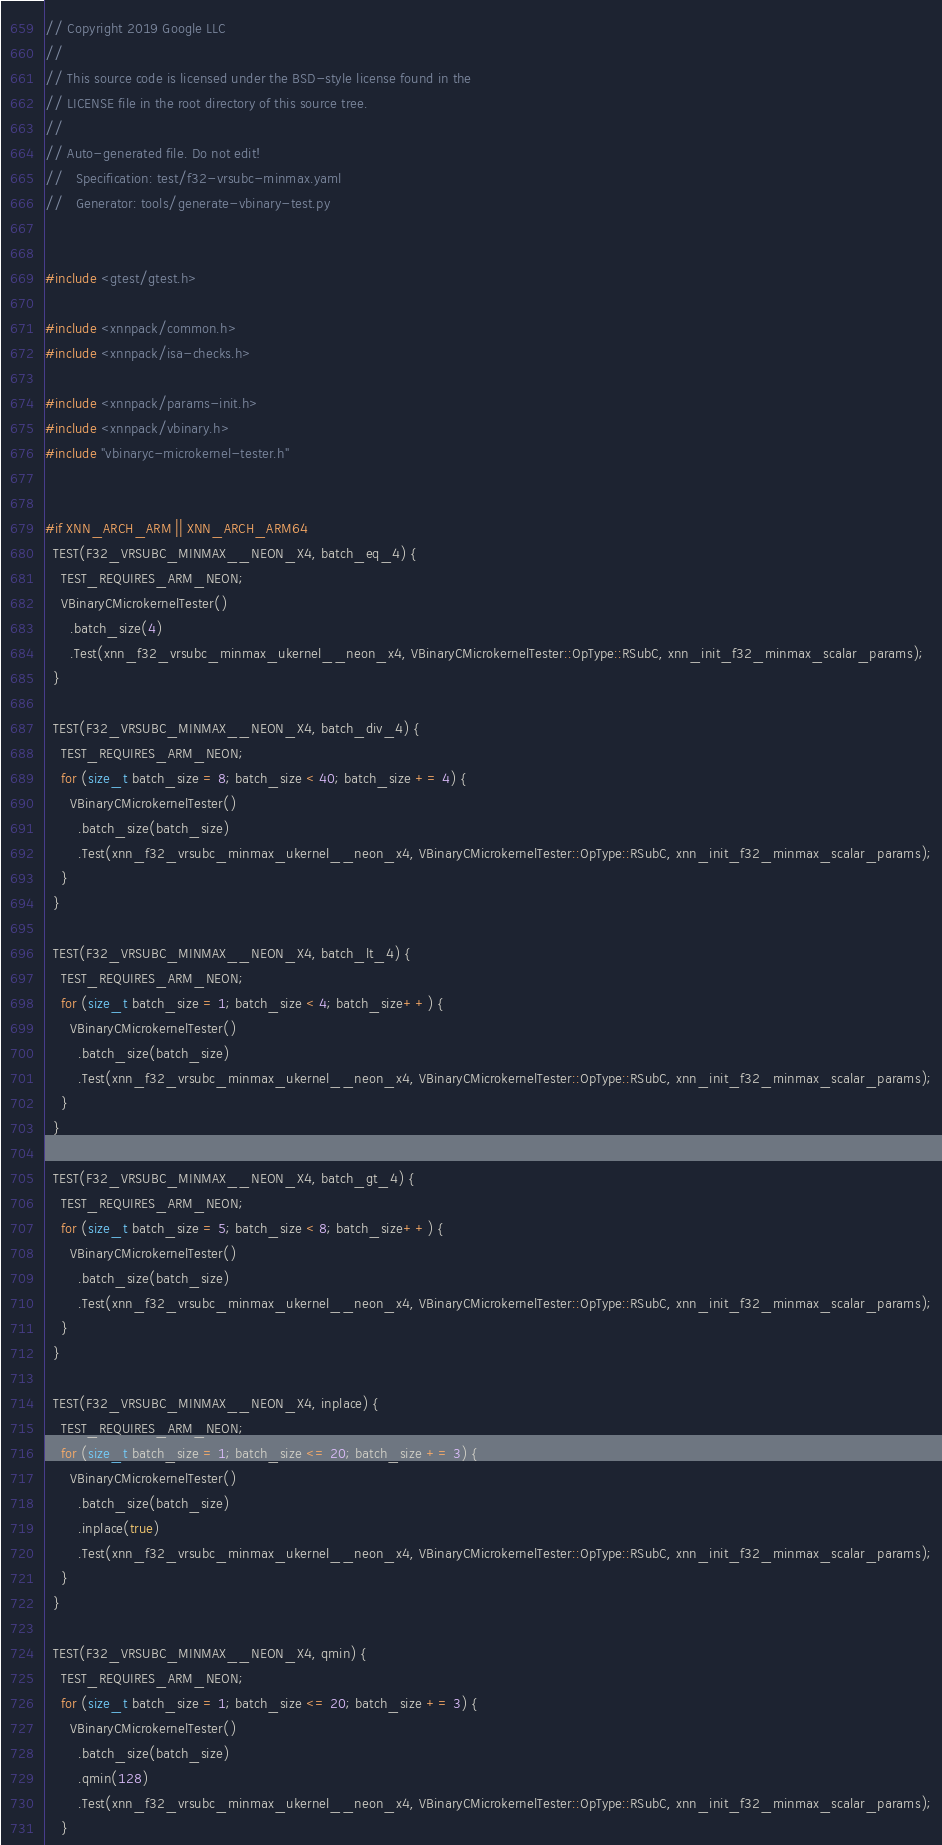<code> <loc_0><loc_0><loc_500><loc_500><_C++_>// Copyright 2019 Google LLC
//
// This source code is licensed under the BSD-style license found in the
// LICENSE file in the root directory of this source tree.
//
// Auto-generated file. Do not edit!
//   Specification: test/f32-vrsubc-minmax.yaml
//   Generator: tools/generate-vbinary-test.py


#include <gtest/gtest.h>

#include <xnnpack/common.h>
#include <xnnpack/isa-checks.h>

#include <xnnpack/params-init.h>
#include <xnnpack/vbinary.h>
#include "vbinaryc-microkernel-tester.h"


#if XNN_ARCH_ARM || XNN_ARCH_ARM64
  TEST(F32_VRSUBC_MINMAX__NEON_X4, batch_eq_4) {
    TEST_REQUIRES_ARM_NEON;
    VBinaryCMicrokernelTester()
      .batch_size(4)
      .Test(xnn_f32_vrsubc_minmax_ukernel__neon_x4, VBinaryCMicrokernelTester::OpType::RSubC, xnn_init_f32_minmax_scalar_params);
  }

  TEST(F32_VRSUBC_MINMAX__NEON_X4, batch_div_4) {
    TEST_REQUIRES_ARM_NEON;
    for (size_t batch_size = 8; batch_size < 40; batch_size += 4) {
      VBinaryCMicrokernelTester()
        .batch_size(batch_size)
        .Test(xnn_f32_vrsubc_minmax_ukernel__neon_x4, VBinaryCMicrokernelTester::OpType::RSubC, xnn_init_f32_minmax_scalar_params);
    }
  }

  TEST(F32_VRSUBC_MINMAX__NEON_X4, batch_lt_4) {
    TEST_REQUIRES_ARM_NEON;
    for (size_t batch_size = 1; batch_size < 4; batch_size++) {
      VBinaryCMicrokernelTester()
        .batch_size(batch_size)
        .Test(xnn_f32_vrsubc_minmax_ukernel__neon_x4, VBinaryCMicrokernelTester::OpType::RSubC, xnn_init_f32_minmax_scalar_params);
    }
  }

  TEST(F32_VRSUBC_MINMAX__NEON_X4, batch_gt_4) {
    TEST_REQUIRES_ARM_NEON;
    for (size_t batch_size = 5; batch_size < 8; batch_size++) {
      VBinaryCMicrokernelTester()
        .batch_size(batch_size)
        .Test(xnn_f32_vrsubc_minmax_ukernel__neon_x4, VBinaryCMicrokernelTester::OpType::RSubC, xnn_init_f32_minmax_scalar_params);
    }
  }

  TEST(F32_VRSUBC_MINMAX__NEON_X4, inplace) {
    TEST_REQUIRES_ARM_NEON;
    for (size_t batch_size = 1; batch_size <= 20; batch_size += 3) {
      VBinaryCMicrokernelTester()
        .batch_size(batch_size)
        .inplace(true)
        .Test(xnn_f32_vrsubc_minmax_ukernel__neon_x4, VBinaryCMicrokernelTester::OpType::RSubC, xnn_init_f32_minmax_scalar_params);
    }
  }

  TEST(F32_VRSUBC_MINMAX__NEON_X4, qmin) {
    TEST_REQUIRES_ARM_NEON;
    for (size_t batch_size = 1; batch_size <= 20; batch_size += 3) {
      VBinaryCMicrokernelTester()
        .batch_size(batch_size)
        .qmin(128)
        .Test(xnn_f32_vrsubc_minmax_ukernel__neon_x4, VBinaryCMicrokernelTester::OpType::RSubC, xnn_init_f32_minmax_scalar_params);
    }</code> 